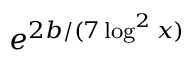Convert formula to latex. <formula><loc_0><loc_0><loc_500><loc_500>e ^ { 2 b / ( 7 \log ^ { 2 } x ) }</formula> 